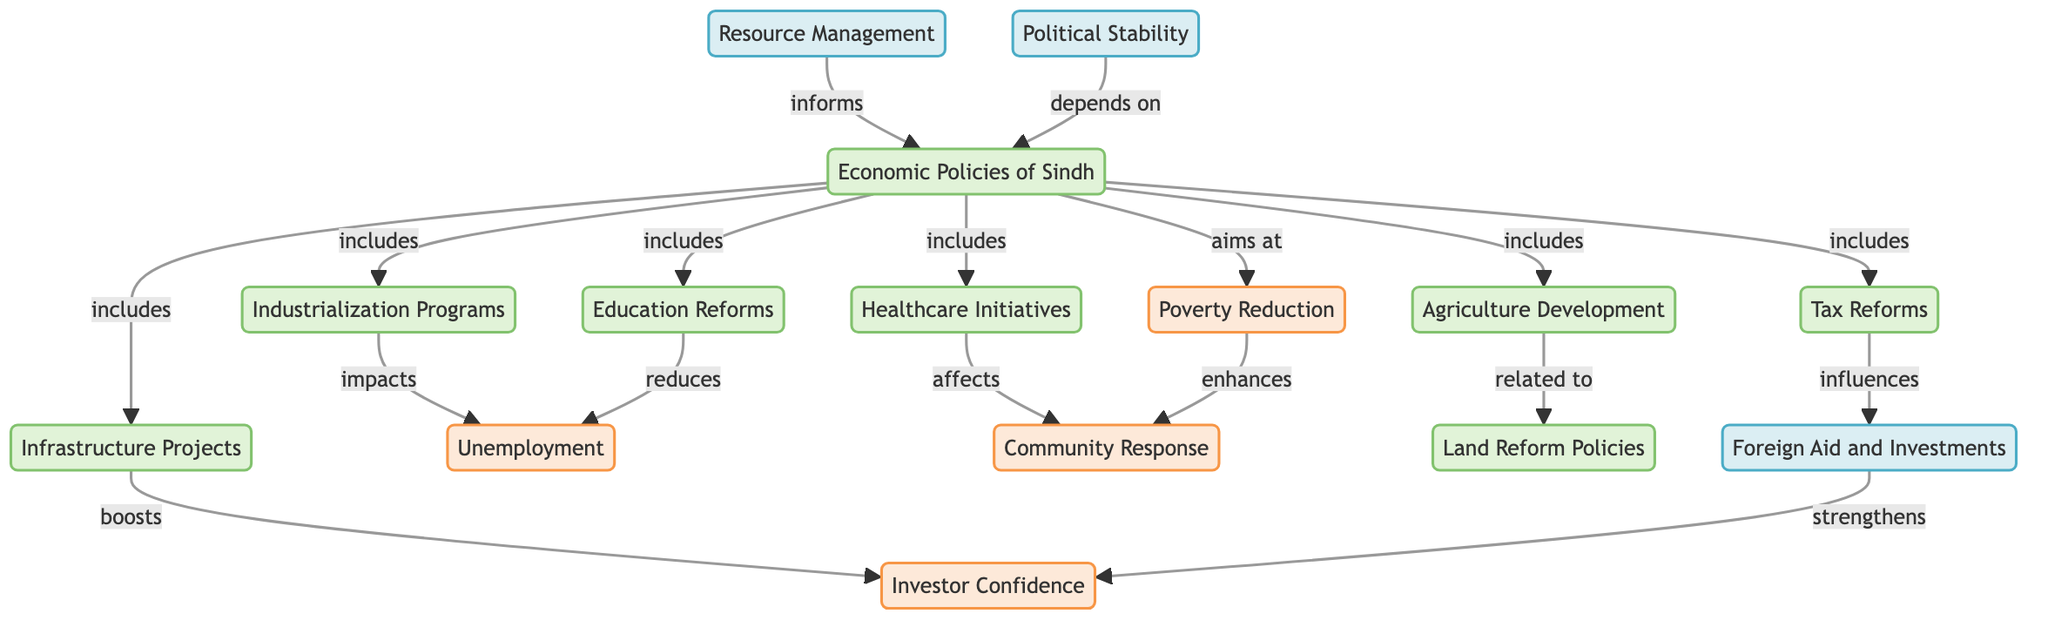What are the main components included in the Economic Policies of Sindh? The diagram lists the main components as Agriculture Development, Industrialization Programs, Infrastructure Projects, Education Reforms, Healthcare Initiatives, and Tax Reforms, which are all connected to the central node Economic Policies of Sindh through the "includes" relationship.
Answer: Agriculture Development, Industrialization Programs, Infrastructure Projects, Education Reforms, Healthcare Initiatives, Tax Reforms How many direct impacts are listed under Economic Policies of Sindh? The diagram shows one main impact node, Poverty Reduction, which is directly connected to Economic Policies of Sindh with an "aims at" relationship. It also has links to Unemployment, Investor Confidence, Community Response, and Foreign Aid, making a total of four direct impact nodes.
Answer: 4 What is the relationship between Industrialization Programs and Unemployment? The connection is indicated by the label "impacts," meaning that Industrialization Programs have an effect on Unemployment, specifically in terms of increasing or reducing job opportunities.
Answer: impacts Which economic policy directly relates to Land Reform Policies? The diagram directly connects the Agriculture Development node to Land Reform Policies with the label "related to," indicating a specific linkage between these two concepts.
Answer: Agriculture Development How does Infrastructure Projects influence Investor Confidence? The relationship is denoted by "boosts" within the diagram, meaning that Infrastructure Projects are expected to create a favorable condition which supports and enhances Investor Confidence in the region.
Answer: boosts Which policies have a dependence on Political Stability? The only policy indicated in the diagram that depends on Political Stability is Economic Policies of Sindh, as noted by the "depends on" connection. This shows a need for a stable political environment for effective economic planning.
Answer: Economic Policies of Sindh How does Foreign Aid affect Investor Confidence? The relationship established in the diagram shows that Foreign Aid strengthens Investor Confidence, suggesting that the influx of foreign investments enhances the overall confidence of investors.
Answer: strengthens What is the role of Resource Management in Economic Policies of Sindh? Resource Management is shown to inform Economic Policies of Sindh on the diagram, indicating its significance in providing the necessary data and strategies to shape these economic policies effectively.
Answer: informs 